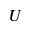<formula> <loc_0><loc_0><loc_500><loc_500>U</formula> 